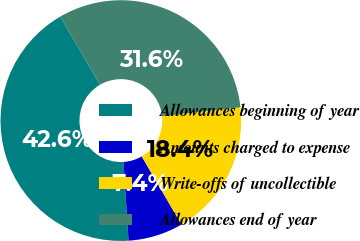Convert chart. <chart><loc_0><loc_0><loc_500><loc_500><pie_chart><fcel>Allowances beginning of year<fcel>Amounts charged to expense<fcel>Write-offs of uncollectible<fcel>Allowances end of year<nl><fcel>42.62%<fcel>7.38%<fcel>18.36%<fcel>31.64%<nl></chart> 